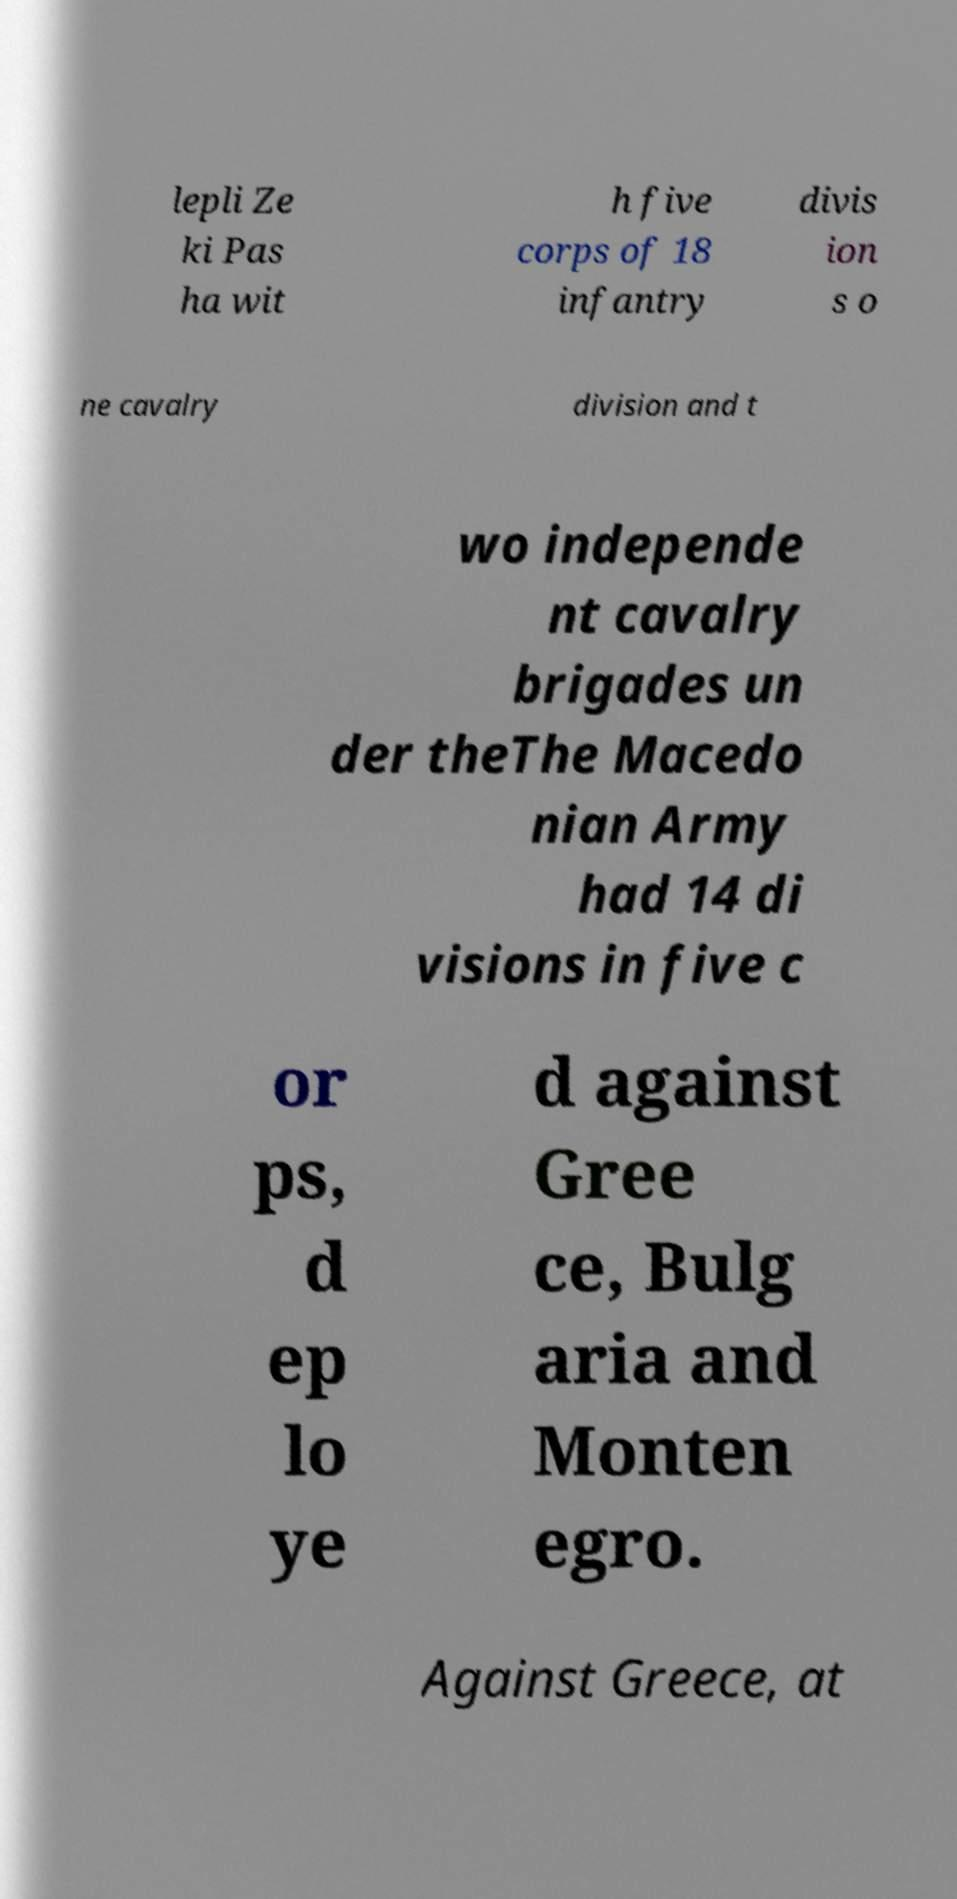Can you read and provide the text displayed in the image?This photo seems to have some interesting text. Can you extract and type it out for me? lepli Ze ki Pas ha wit h five corps of 18 infantry divis ion s o ne cavalry division and t wo independe nt cavalry brigades un der theThe Macedo nian Army had 14 di visions in five c or ps, d ep lo ye d against Gree ce, Bulg aria and Monten egro. Against Greece, at 